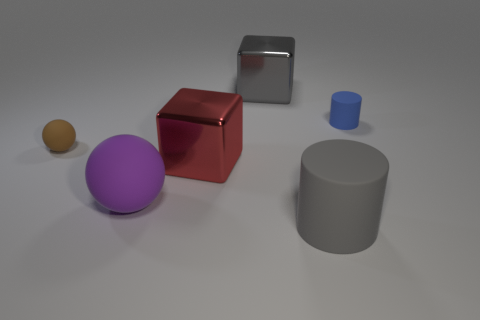Which object in the image is the largest? The largest object in the image appears to be the gray cylinder on the right. It is taller and has a wider diameter than the other objects presented. 